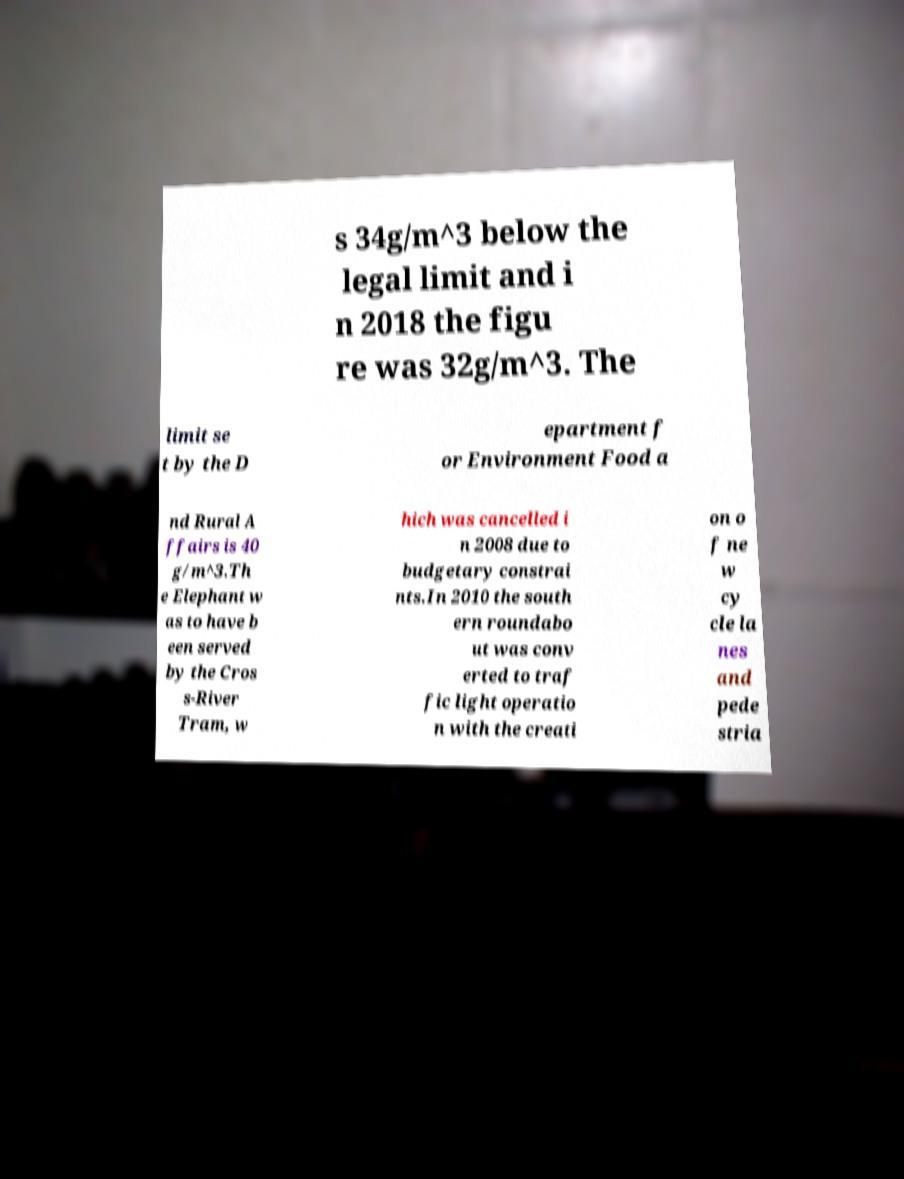Please read and relay the text visible in this image. What does it say? s 34g/m^3 below the legal limit and i n 2018 the figu re was 32g/m^3. The limit se t by the D epartment f or Environment Food a nd Rural A ffairs is 40 g/m^3.Th e Elephant w as to have b een served by the Cros s-River Tram, w hich was cancelled i n 2008 due to budgetary constrai nts.In 2010 the south ern roundabo ut was conv erted to traf fic light operatio n with the creati on o f ne w cy cle la nes and pede stria 